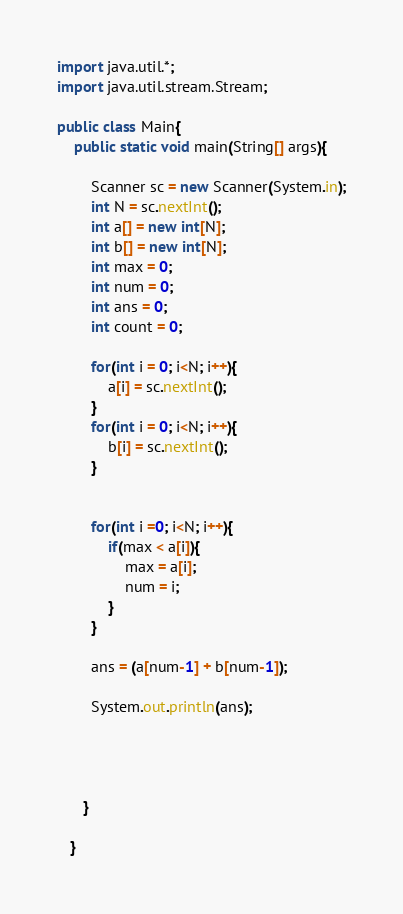<code> <loc_0><loc_0><loc_500><loc_500><_Java_>import java.util.*;
import java.util.stream.Stream;

public class Main{
	public static void main(String[] args){
		
		Scanner sc = new Scanner(System.in);
        int N = sc.nextInt();   
        int a[] = new int[N];
        int b[] = new int[N];
        int max = 0;
        int num = 0;
        int ans = 0;
        int count = 0;
        
        for(int i = 0; i<N; i++){
        	a[i] = sc.nextInt();
        }
        for(int i = 0; i<N; i++){
        	b[i] = sc.nextInt();
        }
        
        
        for(int i =0; i<N; i++){
        	if(max < a[i]){
        		max = a[i];
        		num = i;
        	}
        }
        
        ans = (a[num-1] + b[num-1]);
        
        System.out.println(ans);
        	
        
        
        
      }
      
   }
</code> 